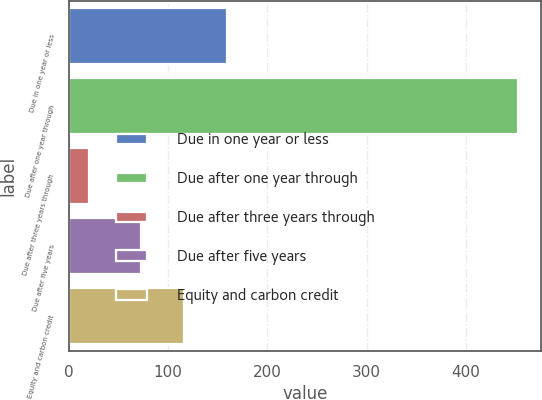Convert chart to OTSL. <chart><loc_0><loc_0><loc_500><loc_500><bar_chart><fcel>Due in one year or less<fcel>Due after one year through<fcel>Due after three years through<fcel>Due after five years<fcel>Equity and carbon credit<nl><fcel>159.4<fcel>453<fcel>21<fcel>73<fcel>116.2<nl></chart> 